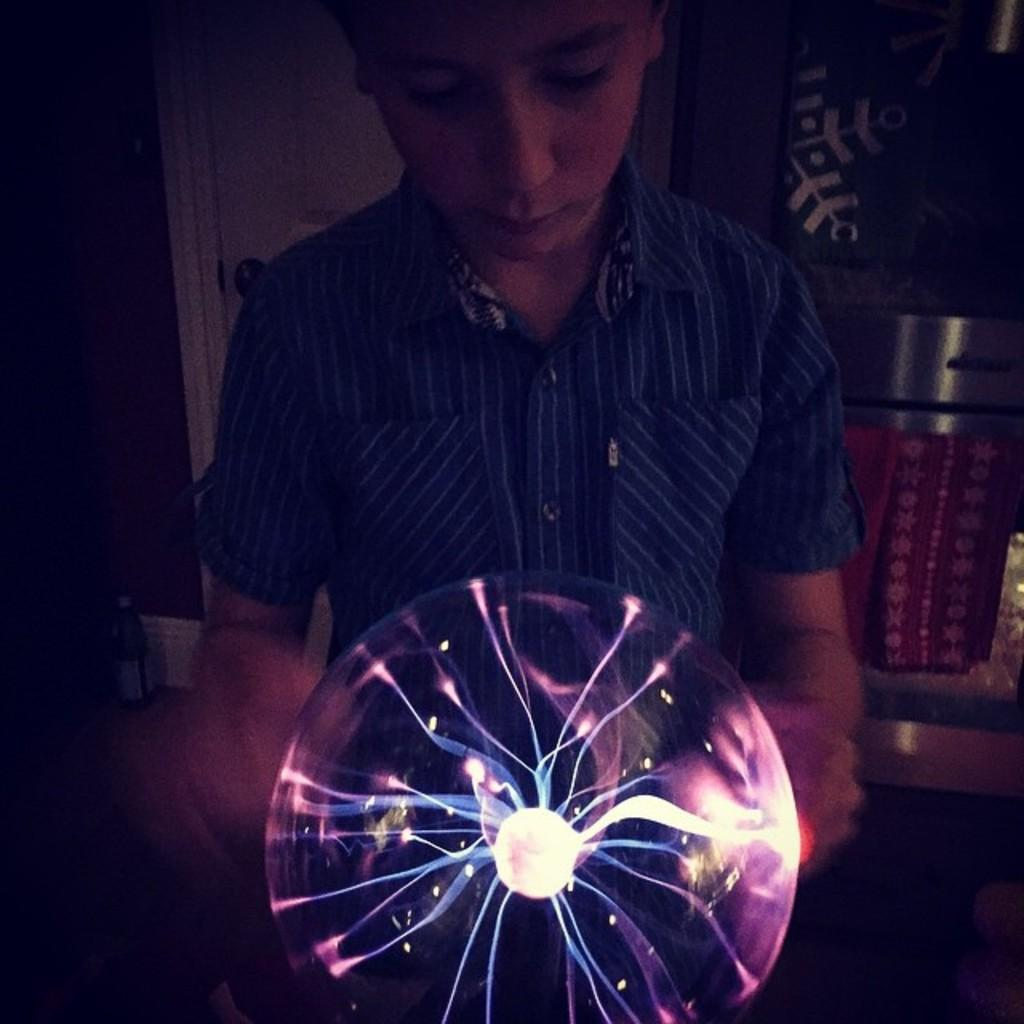Who is the main subject in the image? There is a boy in the image. What is the boy holding in the image? The boy is holding a balloon. What is unique about the balloon? The balloon has lights in it. What color is the shirt the boy is wearing? The boy is wearing a blue color shirt. What can be seen in the background of the image? There is a wall in the background of the image. How many sisters does the boy have in the image? There is no information about the boy's sisters in the image. What type of polish is the boy using on his nails in the image? There is no indication that the boy is using any polish on his nails in the image. 